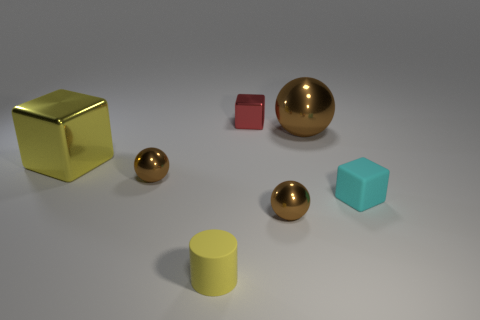Subtract all large spheres. How many spheres are left? 2 Add 1 tiny brown balls. How many objects exist? 8 Subtract all balls. How many objects are left? 4 Add 6 green things. How many green things exist? 6 Subtract 0 cyan balls. How many objects are left? 7 Subtract all small spheres. Subtract all yellow matte cylinders. How many objects are left? 4 Add 4 small cyan rubber objects. How many small cyan rubber objects are left? 5 